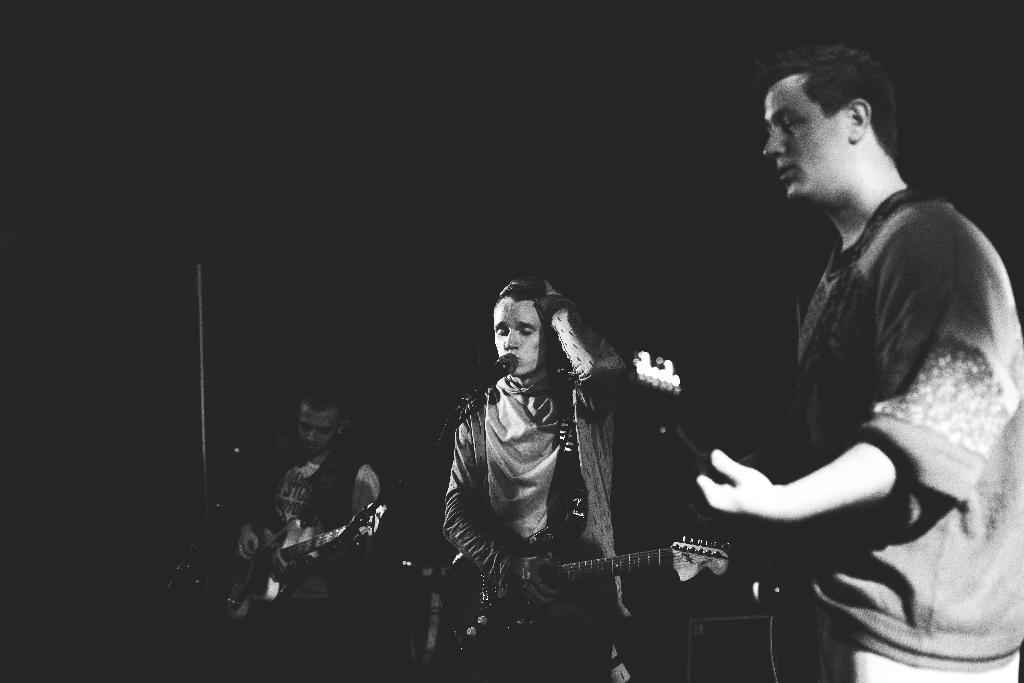How many people are in the image? There are three persons in the image. What are the three persons doing? The three persons are standing and playing the guitar. What object is present in the image that is typically used for amplifying sound? There is a microphone in the image. What type of health issues are the three persons discussing in the image? There is no indication in the image that the three persons are discussing health issues. 